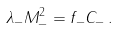<formula> <loc_0><loc_0><loc_500><loc_500>\lambda _ { - } M _ { - } ^ { 2 } = f _ { - } C _ { - } \, .</formula> 